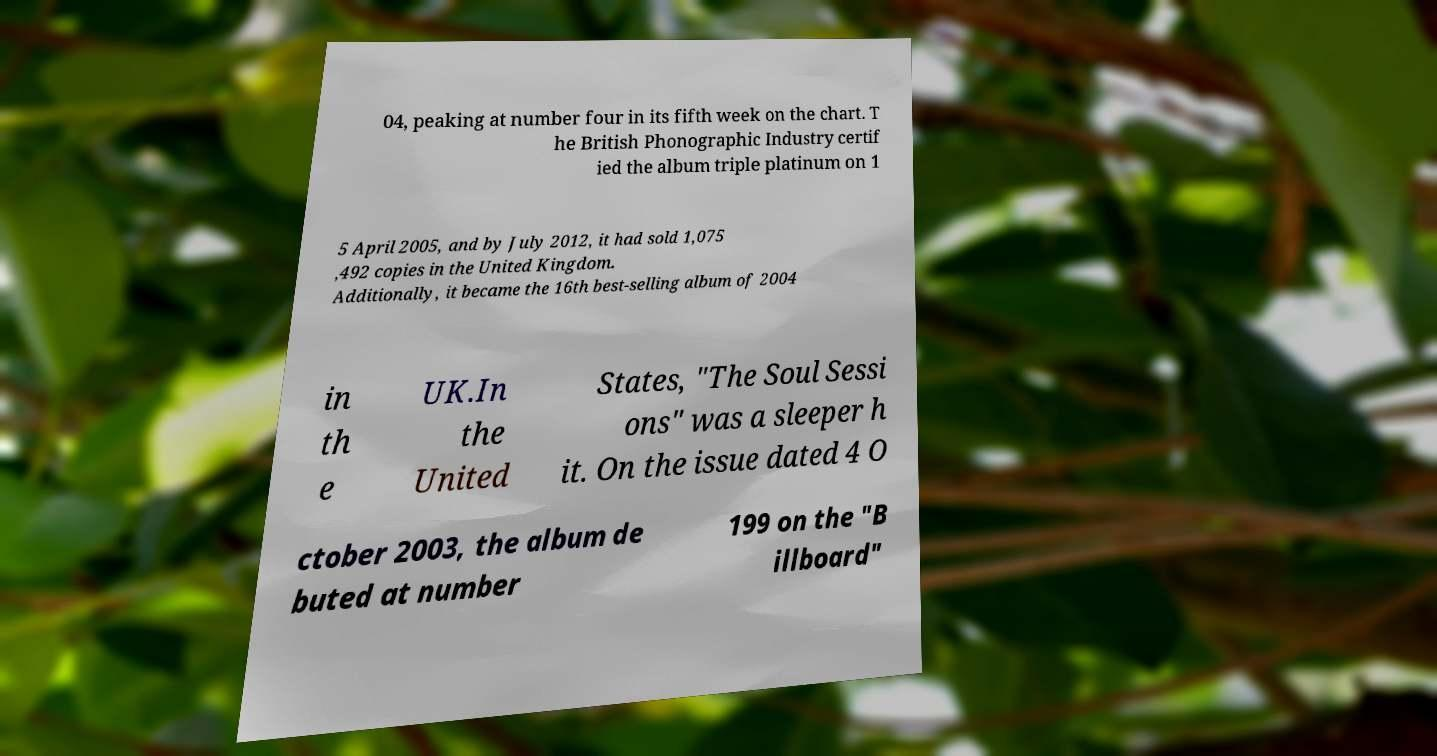Please identify and transcribe the text found in this image. 04, peaking at number four in its fifth week on the chart. T he British Phonographic Industry certif ied the album triple platinum on 1 5 April 2005, and by July 2012, it had sold 1,075 ,492 copies in the United Kingdom. Additionally, it became the 16th best-selling album of 2004 in th e UK.In the United States, "The Soul Sessi ons" was a sleeper h it. On the issue dated 4 O ctober 2003, the album de buted at number 199 on the "B illboard" 